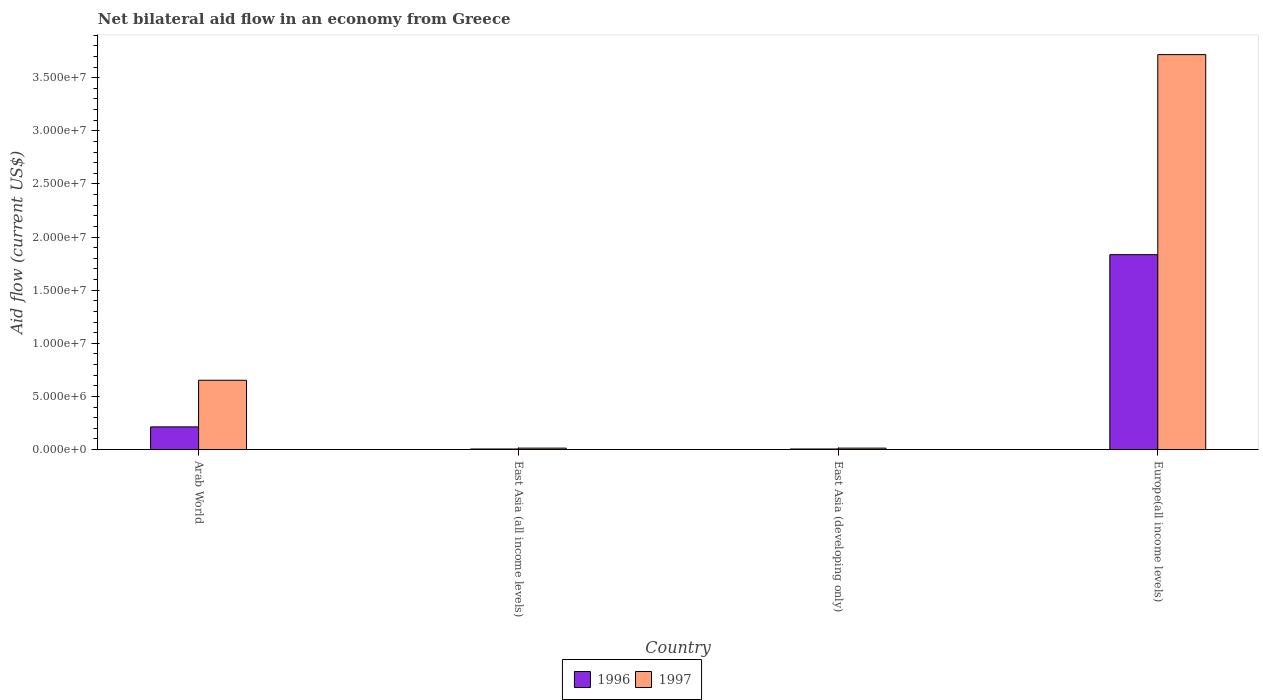How many different coloured bars are there?
Your answer should be very brief. 2. Are the number of bars per tick equal to the number of legend labels?
Make the answer very short. Yes. Are the number of bars on each tick of the X-axis equal?
Give a very brief answer. Yes. How many bars are there on the 3rd tick from the left?
Offer a terse response. 2. How many bars are there on the 2nd tick from the right?
Provide a short and direct response. 2. What is the label of the 4th group of bars from the left?
Give a very brief answer. Europe(all income levels). What is the net bilateral aid flow in 1996 in Europe(all income levels)?
Make the answer very short. 1.83e+07. Across all countries, what is the maximum net bilateral aid flow in 1997?
Your answer should be compact. 3.72e+07. In which country was the net bilateral aid flow in 1997 maximum?
Give a very brief answer. Europe(all income levels). In which country was the net bilateral aid flow in 1997 minimum?
Your answer should be very brief. East Asia (all income levels). What is the total net bilateral aid flow in 1996 in the graph?
Ensure brevity in your answer.  2.06e+07. What is the difference between the net bilateral aid flow in 1997 in East Asia (developing only) and that in Europe(all income levels)?
Ensure brevity in your answer.  -3.70e+07. What is the difference between the net bilateral aid flow in 1997 in Arab World and the net bilateral aid flow in 1996 in Europe(all income levels)?
Offer a terse response. -1.18e+07. What is the average net bilateral aid flow in 1996 per country?
Your response must be concise. 5.14e+06. In how many countries, is the net bilateral aid flow in 1997 greater than 38000000 US$?
Give a very brief answer. 0. What is the ratio of the net bilateral aid flow in 1996 in Arab World to that in East Asia (all income levels)?
Ensure brevity in your answer.  42.6. What is the difference between the highest and the second highest net bilateral aid flow in 1996?
Offer a very short reply. 1.83e+07. What is the difference between the highest and the lowest net bilateral aid flow in 1997?
Your response must be concise. 3.70e+07. What does the 2nd bar from the left in Europe(all income levels) represents?
Your answer should be very brief. 1997. How many bars are there?
Your answer should be very brief. 8. What is the difference between two consecutive major ticks on the Y-axis?
Ensure brevity in your answer.  5.00e+06. Are the values on the major ticks of Y-axis written in scientific E-notation?
Give a very brief answer. Yes. Where does the legend appear in the graph?
Keep it short and to the point. Bottom center. How are the legend labels stacked?
Your answer should be compact. Horizontal. What is the title of the graph?
Make the answer very short. Net bilateral aid flow in an economy from Greece. Does "1971" appear as one of the legend labels in the graph?
Provide a succinct answer. No. What is the Aid flow (current US$) of 1996 in Arab World?
Ensure brevity in your answer.  2.13e+06. What is the Aid flow (current US$) of 1997 in Arab World?
Keep it short and to the point. 6.52e+06. What is the Aid flow (current US$) in 1996 in East Asia (all income levels)?
Your answer should be compact. 5.00e+04. What is the Aid flow (current US$) in 1996 in Europe(all income levels)?
Give a very brief answer. 1.83e+07. What is the Aid flow (current US$) of 1997 in Europe(all income levels)?
Keep it short and to the point. 3.72e+07. Across all countries, what is the maximum Aid flow (current US$) in 1996?
Offer a terse response. 1.83e+07. Across all countries, what is the maximum Aid flow (current US$) of 1997?
Ensure brevity in your answer.  3.72e+07. Across all countries, what is the minimum Aid flow (current US$) in 1997?
Your response must be concise. 1.30e+05. What is the total Aid flow (current US$) of 1996 in the graph?
Give a very brief answer. 2.06e+07. What is the total Aid flow (current US$) in 1997 in the graph?
Your answer should be very brief. 4.40e+07. What is the difference between the Aid flow (current US$) of 1996 in Arab World and that in East Asia (all income levels)?
Your answer should be compact. 2.08e+06. What is the difference between the Aid flow (current US$) in 1997 in Arab World and that in East Asia (all income levels)?
Provide a short and direct response. 6.39e+06. What is the difference between the Aid flow (current US$) of 1996 in Arab World and that in East Asia (developing only)?
Your answer should be compact. 2.08e+06. What is the difference between the Aid flow (current US$) in 1997 in Arab World and that in East Asia (developing only)?
Give a very brief answer. 6.39e+06. What is the difference between the Aid flow (current US$) of 1996 in Arab World and that in Europe(all income levels)?
Offer a very short reply. -1.62e+07. What is the difference between the Aid flow (current US$) of 1997 in Arab World and that in Europe(all income levels)?
Your response must be concise. -3.06e+07. What is the difference between the Aid flow (current US$) in 1996 in East Asia (all income levels) and that in East Asia (developing only)?
Give a very brief answer. 0. What is the difference between the Aid flow (current US$) of 1996 in East Asia (all income levels) and that in Europe(all income levels)?
Ensure brevity in your answer.  -1.83e+07. What is the difference between the Aid flow (current US$) of 1997 in East Asia (all income levels) and that in Europe(all income levels)?
Provide a succinct answer. -3.70e+07. What is the difference between the Aid flow (current US$) in 1996 in East Asia (developing only) and that in Europe(all income levels)?
Provide a succinct answer. -1.83e+07. What is the difference between the Aid flow (current US$) in 1997 in East Asia (developing only) and that in Europe(all income levels)?
Offer a terse response. -3.70e+07. What is the difference between the Aid flow (current US$) in 1996 in Arab World and the Aid flow (current US$) in 1997 in East Asia (developing only)?
Your response must be concise. 2.00e+06. What is the difference between the Aid flow (current US$) of 1996 in Arab World and the Aid flow (current US$) of 1997 in Europe(all income levels)?
Provide a short and direct response. -3.50e+07. What is the difference between the Aid flow (current US$) of 1996 in East Asia (all income levels) and the Aid flow (current US$) of 1997 in East Asia (developing only)?
Provide a short and direct response. -8.00e+04. What is the difference between the Aid flow (current US$) of 1996 in East Asia (all income levels) and the Aid flow (current US$) of 1997 in Europe(all income levels)?
Your response must be concise. -3.71e+07. What is the difference between the Aid flow (current US$) of 1996 in East Asia (developing only) and the Aid flow (current US$) of 1997 in Europe(all income levels)?
Offer a very short reply. -3.71e+07. What is the average Aid flow (current US$) in 1996 per country?
Provide a succinct answer. 5.14e+06. What is the average Aid flow (current US$) in 1997 per country?
Offer a terse response. 1.10e+07. What is the difference between the Aid flow (current US$) in 1996 and Aid flow (current US$) in 1997 in Arab World?
Offer a terse response. -4.39e+06. What is the difference between the Aid flow (current US$) of 1996 and Aid flow (current US$) of 1997 in East Asia (developing only)?
Provide a succinct answer. -8.00e+04. What is the difference between the Aid flow (current US$) of 1996 and Aid flow (current US$) of 1997 in Europe(all income levels)?
Ensure brevity in your answer.  -1.88e+07. What is the ratio of the Aid flow (current US$) in 1996 in Arab World to that in East Asia (all income levels)?
Offer a very short reply. 42.6. What is the ratio of the Aid flow (current US$) in 1997 in Arab World to that in East Asia (all income levels)?
Make the answer very short. 50.15. What is the ratio of the Aid flow (current US$) of 1996 in Arab World to that in East Asia (developing only)?
Ensure brevity in your answer.  42.6. What is the ratio of the Aid flow (current US$) of 1997 in Arab World to that in East Asia (developing only)?
Make the answer very short. 50.15. What is the ratio of the Aid flow (current US$) in 1996 in Arab World to that in Europe(all income levels)?
Give a very brief answer. 0.12. What is the ratio of the Aid flow (current US$) in 1997 in Arab World to that in Europe(all income levels)?
Make the answer very short. 0.18. What is the ratio of the Aid flow (current US$) in 1996 in East Asia (all income levels) to that in East Asia (developing only)?
Offer a terse response. 1. What is the ratio of the Aid flow (current US$) of 1996 in East Asia (all income levels) to that in Europe(all income levels)?
Offer a terse response. 0. What is the ratio of the Aid flow (current US$) of 1997 in East Asia (all income levels) to that in Europe(all income levels)?
Ensure brevity in your answer.  0. What is the ratio of the Aid flow (current US$) in 1996 in East Asia (developing only) to that in Europe(all income levels)?
Make the answer very short. 0. What is the ratio of the Aid flow (current US$) in 1997 in East Asia (developing only) to that in Europe(all income levels)?
Provide a succinct answer. 0. What is the difference between the highest and the second highest Aid flow (current US$) in 1996?
Offer a very short reply. 1.62e+07. What is the difference between the highest and the second highest Aid flow (current US$) of 1997?
Ensure brevity in your answer.  3.06e+07. What is the difference between the highest and the lowest Aid flow (current US$) in 1996?
Offer a terse response. 1.83e+07. What is the difference between the highest and the lowest Aid flow (current US$) of 1997?
Ensure brevity in your answer.  3.70e+07. 